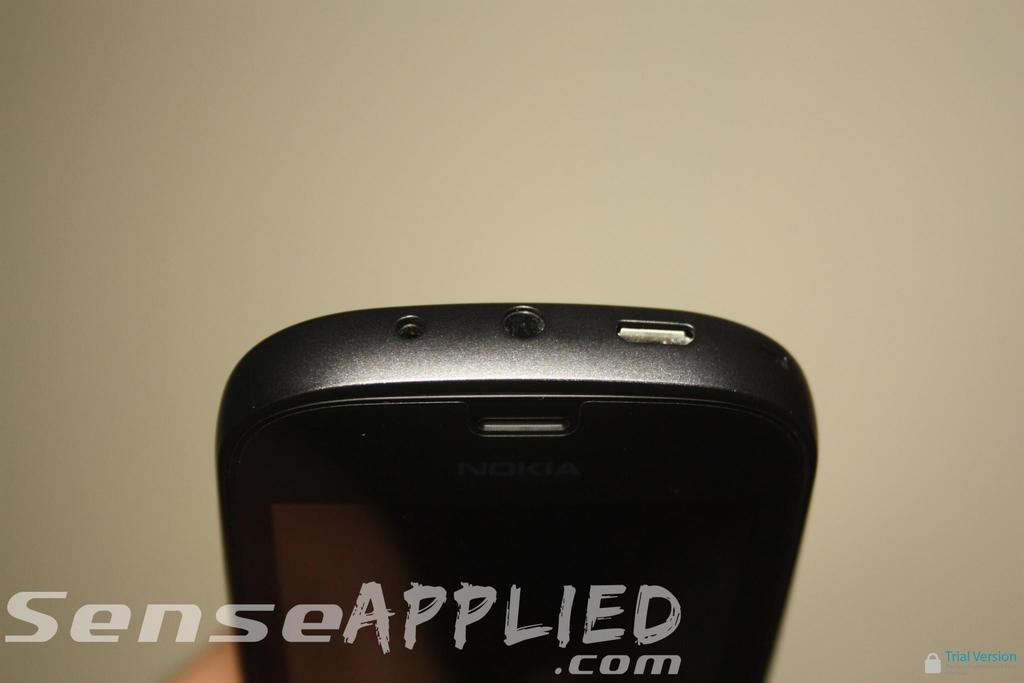Provide a one-sentence caption for the provided image. the bottom of a phone being shown with a watermark text across that reads senseapplied.com. 